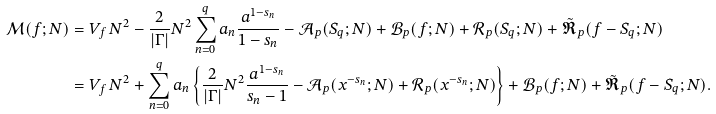<formula> <loc_0><loc_0><loc_500><loc_500>\mathcal { M } ( f ; N ) & = V _ { f } \, N ^ { 2 } - \frac { 2 } { \left | \Gamma \right | } N ^ { 2 } \sum _ { n = 0 } ^ { q } a _ { n } \frac { a ^ { 1 - s _ { n } } } { 1 - s _ { n } } - \mathcal { A } _ { p } ( S _ { q } ; N ) + \mathcal { B } _ { p } ( f ; N ) + \mathcal { R } _ { p } ( S _ { q } ; N ) + \tilde { \mathfrak { R } } _ { p } ( f - S _ { q } ; N ) \\ & = V _ { f } \, N ^ { 2 } + \sum _ { n = 0 } ^ { q } a _ { n } \left \{ \frac { 2 } { \left | \Gamma \right | } N ^ { 2 } \frac { a ^ { 1 - s _ { n } } } { s _ { n } - 1 } - \mathcal { A } _ { p } ( x ^ { - s _ { n } } ; N ) + \mathcal { R } _ { p } ( x ^ { - s _ { n } } ; N ) \right \} + \mathcal { B } _ { p } ( f ; N ) + \tilde { \mathfrak { R } } _ { p } ( f - S _ { q } ; N ) .</formula> 